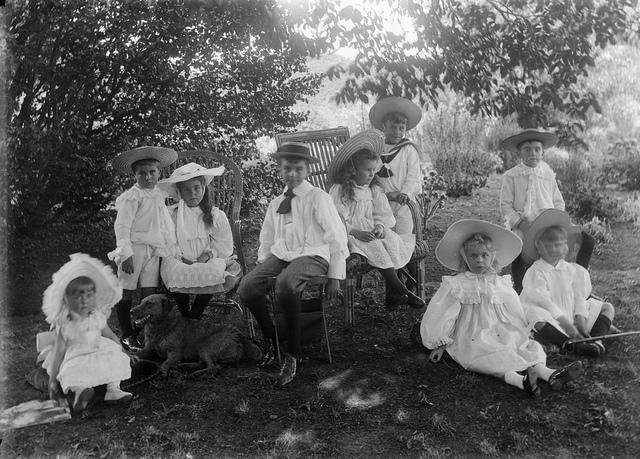How many chairs are there?
Give a very brief answer. 2. How many people are visible?
Give a very brief answer. 9. 